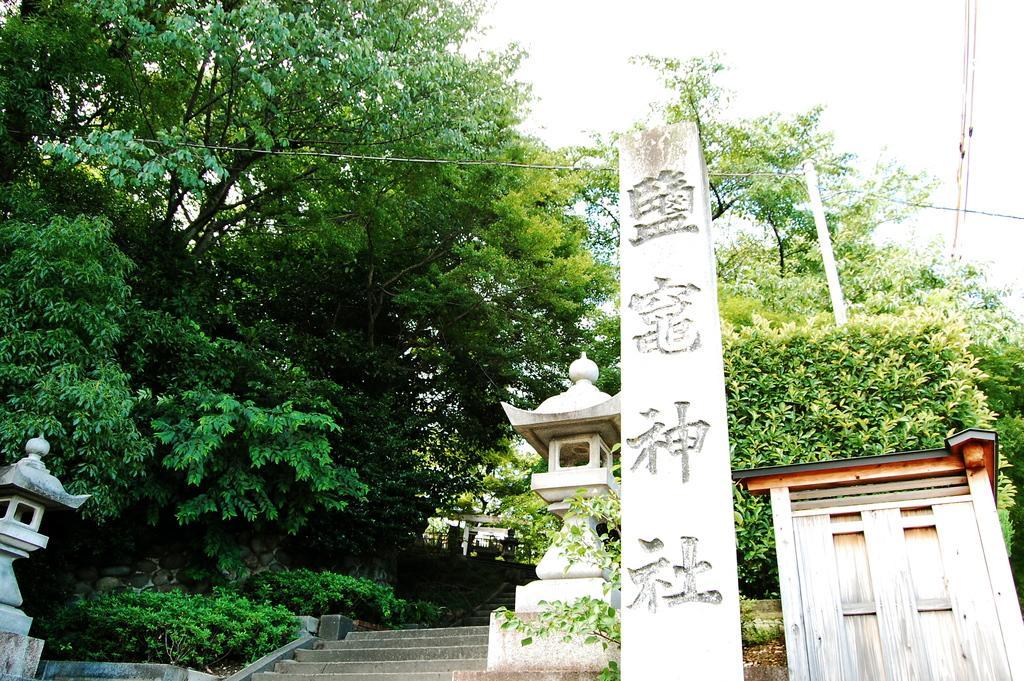Describe this image in one or two sentences. In this image in the front there is a pole and on the pole there are some symbols. In the background there are trees, there are steps and on the right side there is a door and on the left side there are pillars. 